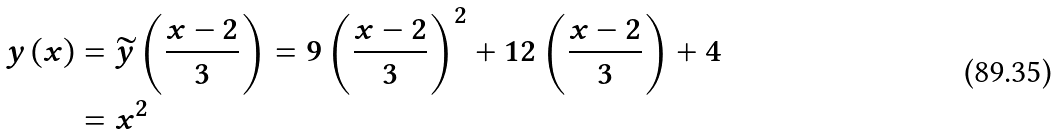<formula> <loc_0><loc_0><loc_500><loc_500>y \left ( x \right ) & = \widetilde { y } \left ( \frac { x - 2 } { 3 } \right ) = 9 \left ( \frac { x - 2 } { 3 } \right ) ^ { 2 } + 1 2 \left ( \frac { x - 2 } { 3 } \right ) + 4 \\ & = x ^ { 2 }</formula> 